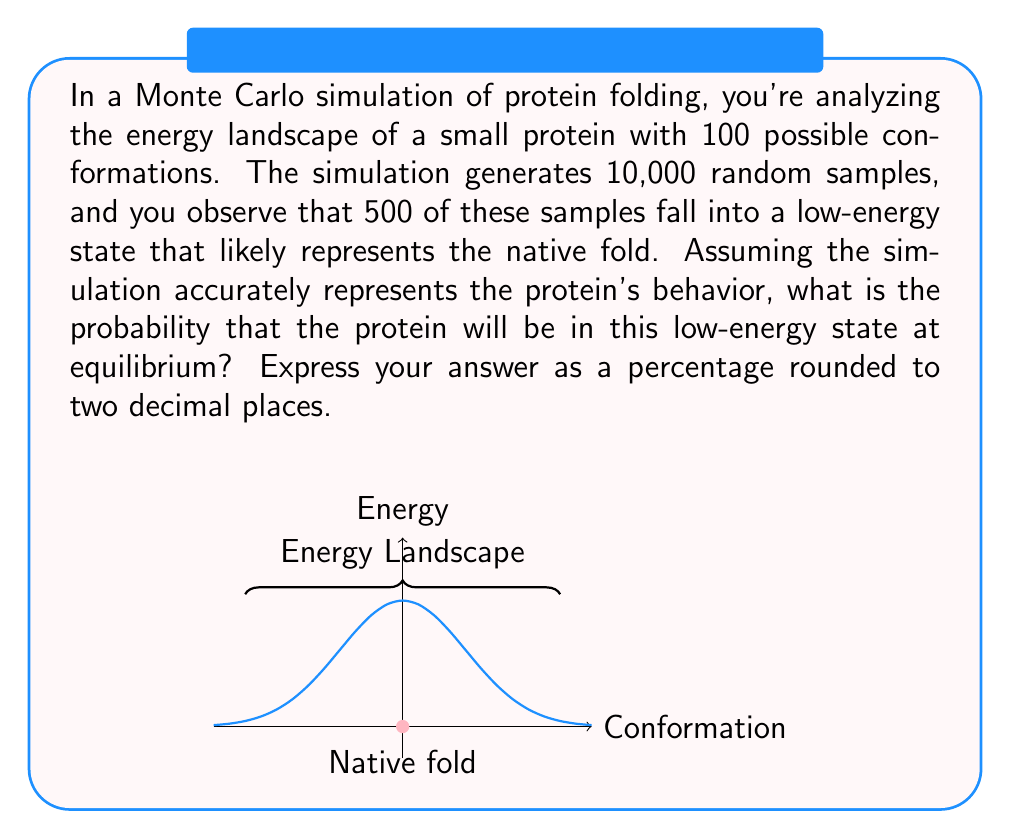Solve this math problem. To solve this problem, we'll follow these steps:

1) In Monte Carlo simulations, the probability of a state is proportional to the number of times it is sampled, given a large number of samples.

2) We have:
   - Total number of samples: $N = 10,000$
   - Number of samples in the low-energy state: $n = 500$

3) The probability $p$ of the protein being in the low-energy state is:

   $$p = \frac{n}{N} = \frac{500}{10,000} = 0.05$$

4) To express this as a percentage, we multiply by 100:

   $$p\% = 0.05 \times 100 = 5\%$$

5) The question asks for the result rounded to two decimal places. Since 5% already has only one decimal place (which is 0), no further rounding is necessary.

This result suggests that at equilibrium, the protein has a 5% chance of being in this particular low-energy state, which likely represents its native fold.
Answer: 5.00% 